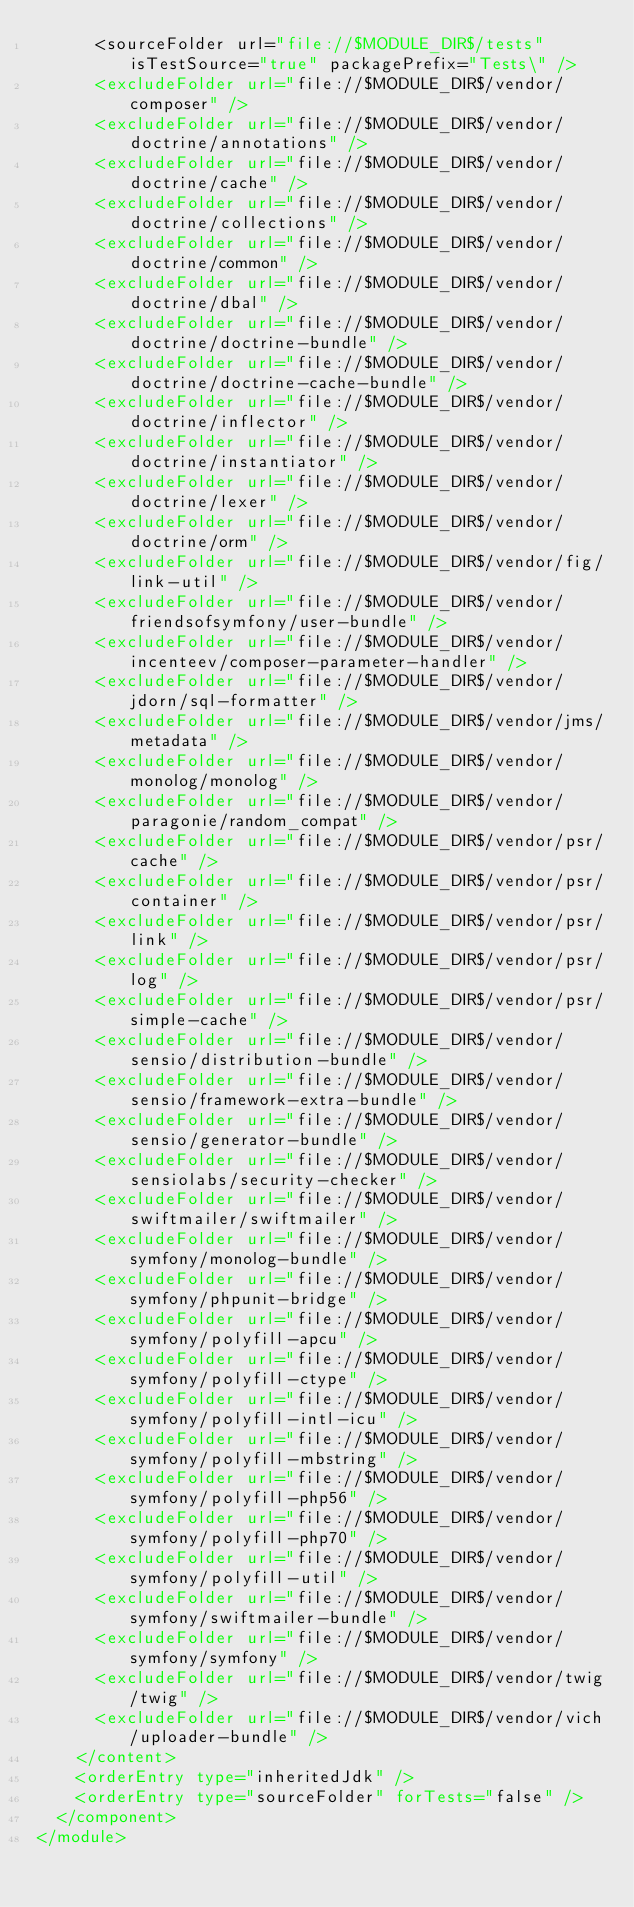Convert code to text. <code><loc_0><loc_0><loc_500><loc_500><_XML_>      <sourceFolder url="file://$MODULE_DIR$/tests" isTestSource="true" packagePrefix="Tests\" />
      <excludeFolder url="file://$MODULE_DIR$/vendor/composer" />
      <excludeFolder url="file://$MODULE_DIR$/vendor/doctrine/annotations" />
      <excludeFolder url="file://$MODULE_DIR$/vendor/doctrine/cache" />
      <excludeFolder url="file://$MODULE_DIR$/vendor/doctrine/collections" />
      <excludeFolder url="file://$MODULE_DIR$/vendor/doctrine/common" />
      <excludeFolder url="file://$MODULE_DIR$/vendor/doctrine/dbal" />
      <excludeFolder url="file://$MODULE_DIR$/vendor/doctrine/doctrine-bundle" />
      <excludeFolder url="file://$MODULE_DIR$/vendor/doctrine/doctrine-cache-bundle" />
      <excludeFolder url="file://$MODULE_DIR$/vendor/doctrine/inflector" />
      <excludeFolder url="file://$MODULE_DIR$/vendor/doctrine/instantiator" />
      <excludeFolder url="file://$MODULE_DIR$/vendor/doctrine/lexer" />
      <excludeFolder url="file://$MODULE_DIR$/vendor/doctrine/orm" />
      <excludeFolder url="file://$MODULE_DIR$/vendor/fig/link-util" />
      <excludeFolder url="file://$MODULE_DIR$/vendor/friendsofsymfony/user-bundle" />
      <excludeFolder url="file://$MODULE_DIR$/vendor/incenteev/composer-parameter-handler" />
      <excludeFolder url="file://$MODULE_DIR$/vendor/jdorn/sql-formatter" />
      <excludeFolder url="file://$MODULE_DIR$/vendor/jms/metadata" />
      <excludeFolder url="file://$MODULE_DIR$/vendor/monolog/monolog" />
      <excludeFolder url="file://$MODULE_DIR$/vendor/paragonie/random_compat" />
      <excludeFolder url="file://$MODULE_DIR$/vendor/psr/cache" />
      <excludeFolder url="file://$MODULE_DIR$/vendor/psr/container" />
      <excludeFolder url="file://$MODULE_DIR$/vendor/psr/link" />
      <excludeFolder url="file://$MODULE_DIR$/vendor/psr/log" />
      <excludeFolder url="file://$MODULE_DIR$/vendor/psr/simple-cache" />
      <excludeFolder url="file://$MODULE_DIR$/vendor/sensio/distribution-bundle" />
      <excludeFolder url="file://$MODULE_DIR$/vendor/sensio/framework-extra-bundle" />
      <excludeFolder url="file://$MODULE_DIR$/vendor/sensio/generator-bundle" />
      <excludeFolder url="file://$MODULE_DIR$/vendor/sensiolabs/security-checker" />
      <excludeFolder url="file://$MODULE_DIR$/vendor/swiftmailer/swiftmailer" />
      <excludeFolder url="file://$MODULE_DIR$/vendor/symfony/monolog-bundle" />
      <excludeFolder url="file://$MODULE_DIR$/vendor/symfony/phpunit-bridge" />
      <excludeFolder url="file://$MODULE_DIR$/vendor/symfony/polyfill-apcu" />
      <excludeFolder url="file://$MODULE_DIR$/vendor/symfony/polyfill-ctype" />
      <excludeFolder url="file://$MODULE_DIR$/vendor/symfony/polyfill-intl-icu" />
      <excludeFolder url="file://$MODULE_DIR$/vendor/symfony/polyfill-mbstring" />
      <excludeFolder url="file://$MODULE_DIR$/vendor/symfony/polyfill-php56" />
      <excludeFolder url="file://$MODULE_DIR$/vendor/symfony/polyfill-php70" />
      <excludeFolder url="file://$MODULE_DIR$/vendor/symfony/polyfill-util" />
      <excludeFolder url="file://$MODULE_DIR$/vendor/symfony/swiftmailer-bundle" />
      <excludeFolder url="file://$MODULE_DIR$/vendor/symfony/symfony" />
      <excludeFolder url="file://$MODULE_DIR$/vendor/twig/twig" />
      <excludeFolder url="file://$MODULE_DIR$/vendor/vich/uploader-bundle" />
    </content>
    <orderEntry type="inheritedJdk" />
    <orderEntry type="sourceFolder" forTests="false" />
  </component>
</module></code> 